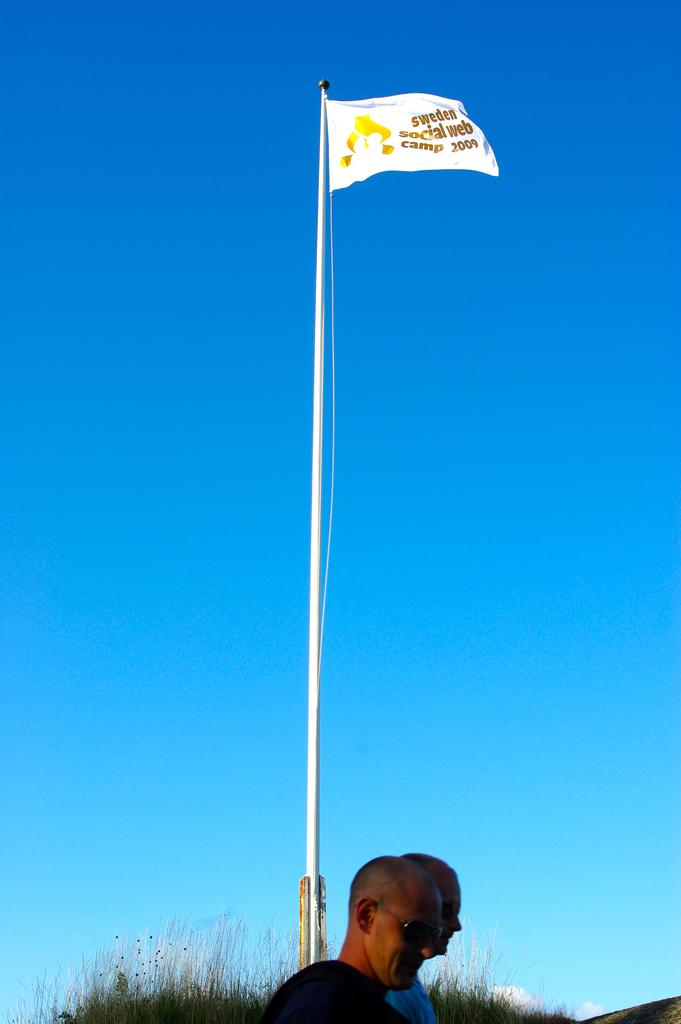How many people are in the foreground of the picture? There are two people in the foreground of the picture. What can be seen in the background of the picture? There are plants in the background of the picture. What is located in the center of the picture? There is a flag in the center of the picture, and there is also a flagpole. What is the condition of the sky in the picture? The sky is clear in the picture. How many pigs are visible in the image? There are no pigs present in the image. Can you tell me what type of vegetable is growing in the background? The provided facts do not mention any specific vegetable growing in the background; only plants are mentioned. 